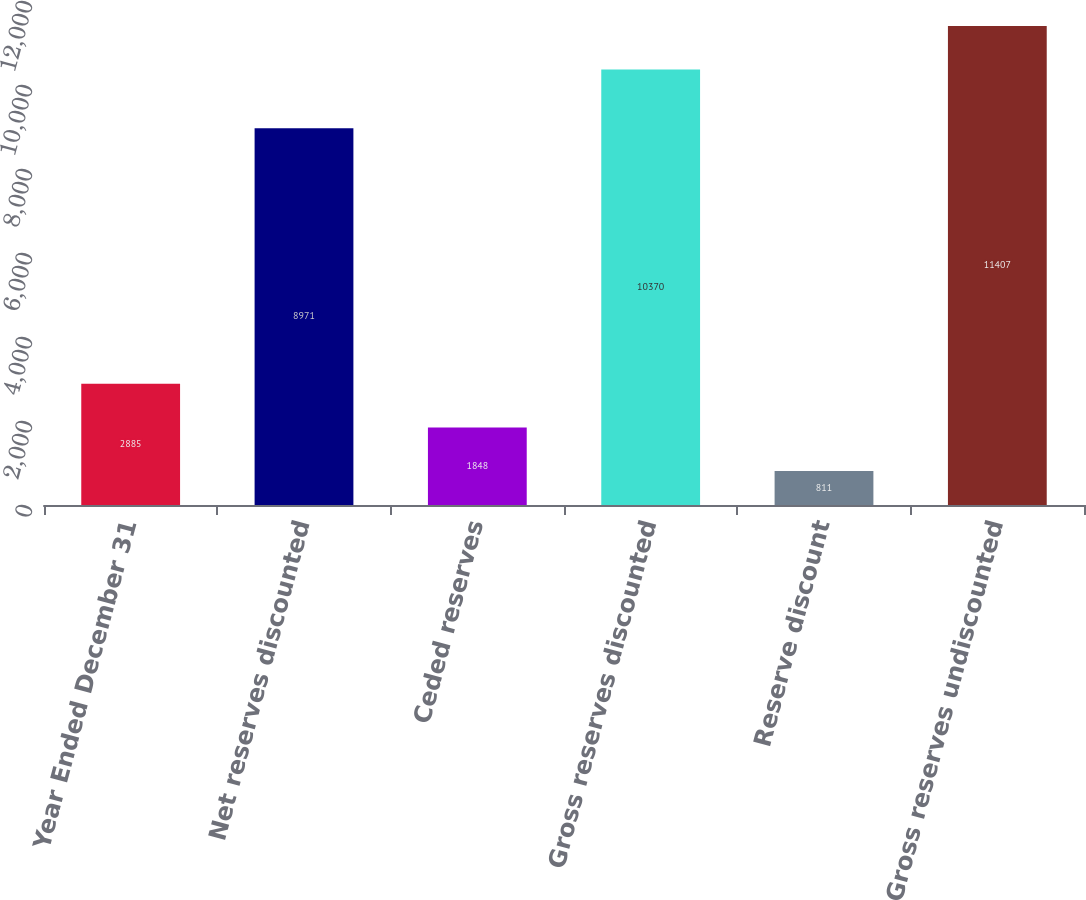<chart> <loc_0><loc_0><loc_500><loc_500><bar_chart><fcel>Year Ended December 31<fcel>Net reserves discounted<fcel>Ceded reserves<fcel>Gross reserves discounted<fcel>Reserve discount<fcel>Gross reserves undiscounted<nl><fcel>2885<fcel>8971<fcel>1848<fcel>10370<fcel>811<fcel>11407<nl></chart> 